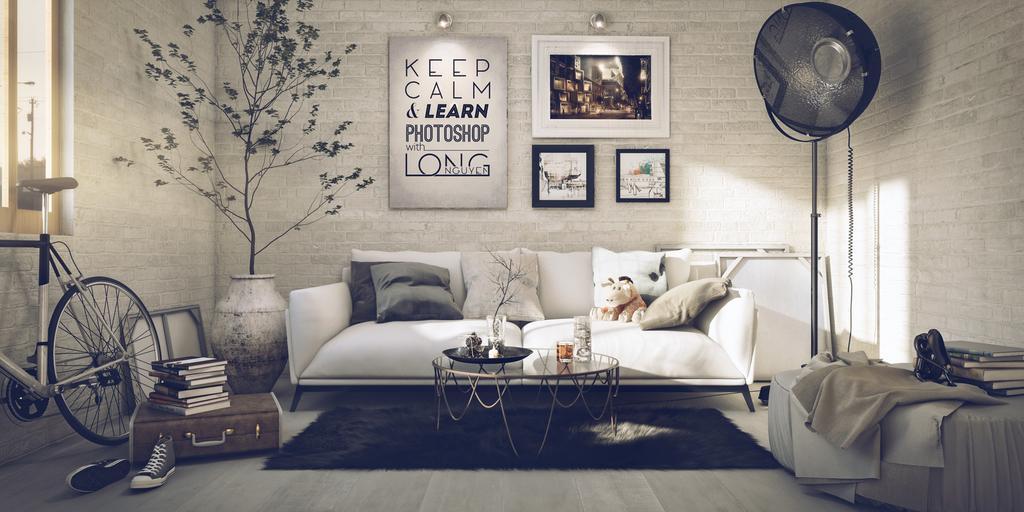Please provide a concise description of this image. In this picture we can see the couch, in front there is a table on it few objects are placed on it, behind we can see some frames to the wall, side we can see potted plant and bicycle along with some books placed on the table, we can see windows to the wall. 